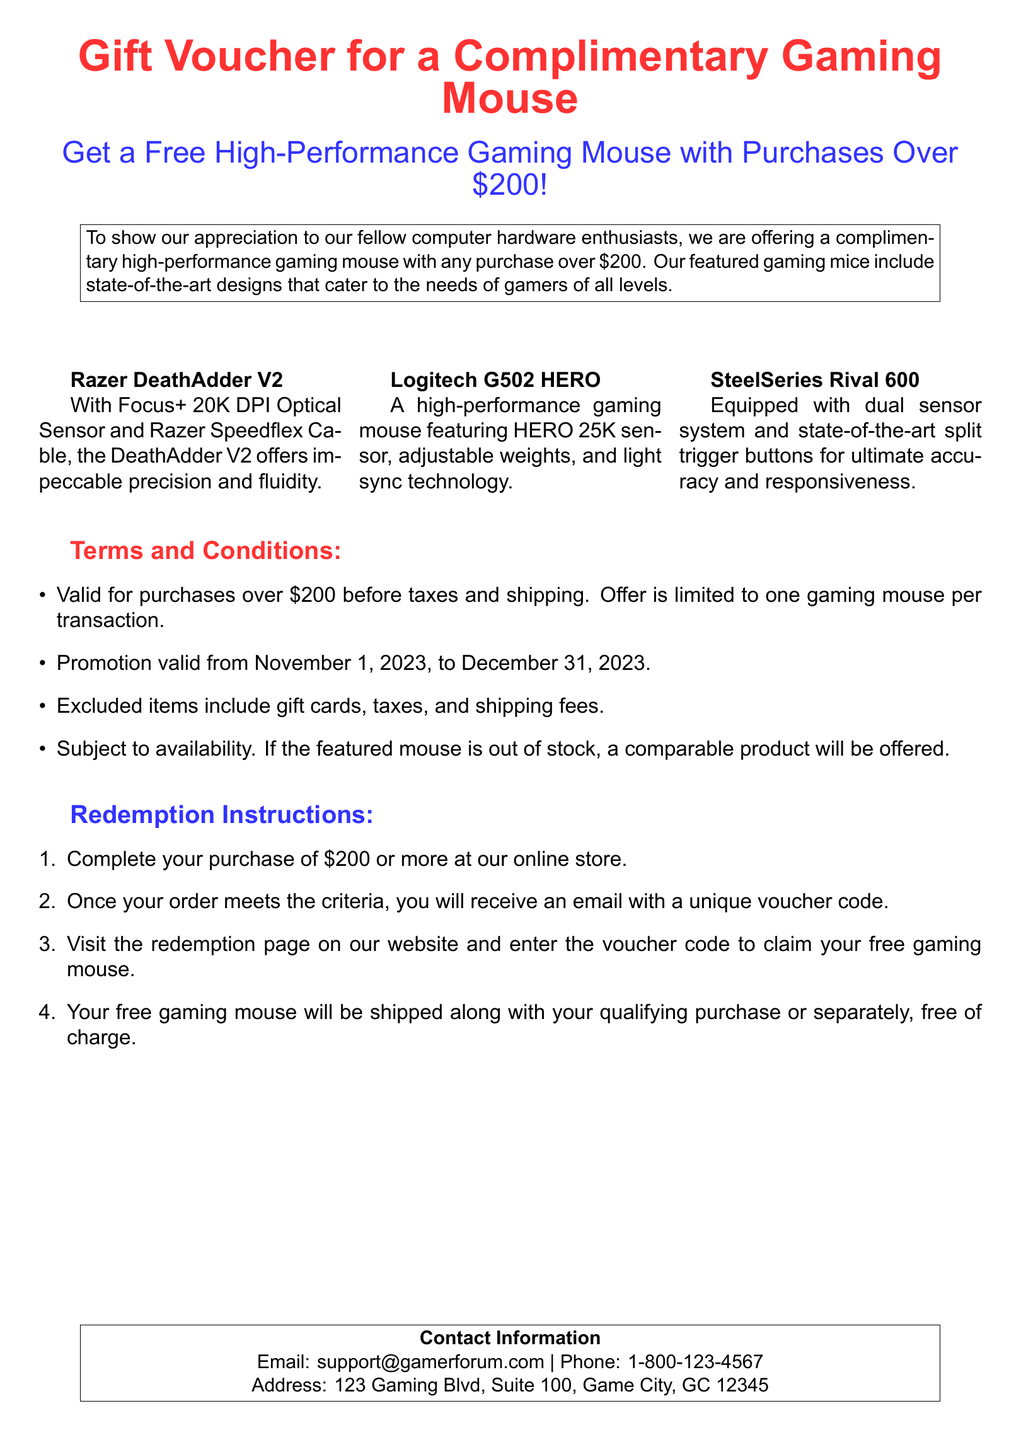What is the offer for a complimentary gaming mouse? The offer states that a free high-performance gaming mouse is available with any purchase over $200.
Answer: Free high-performance gaming mouse What is the minimum purchase amount required for the gift voucher? The minimum purchase amount specified in the document is $200, before taxes and shipping.
Answer: $200 What is the duration of the promotion? The promotion is valid from November 1, 2023, to December 31, 2023.
Answer: November 1, 2023, to December 31, 2023 How many gaming mice can be claimed per transaction? The document explicitly states that the offer is limited to one gaming mouse per transaction.
Answer: One Which gaming mouse features a Focus+ 20K DPI Optical Sensor? The Razer DeathAdder V2 is the gaming mouse that features a Focus+ 20K DPI Optical Sensor.
Answer: Razer DeathAdder V2 What should a customer do to claim their free gaming mouse? To claim the free gaming mouse, the customer needs to complete their purchase of $200 or more and follow the redemption instructions.
Answer: Complete the purchase Are gift cards included in the eligible purchase items for this offer? The terms and conditions state that gift cards are excluded from the promotion.
Answer: No What will happen if the featured mouse is out of stock? If the featured mouse is out of stock, a comparable product will be offered according to the terms.
Answer: A comparable product What email address is provided for customer support? The document lists support@gamerforum.com as the email for customer support inquiries.
Answer: support@gamerforum.com 